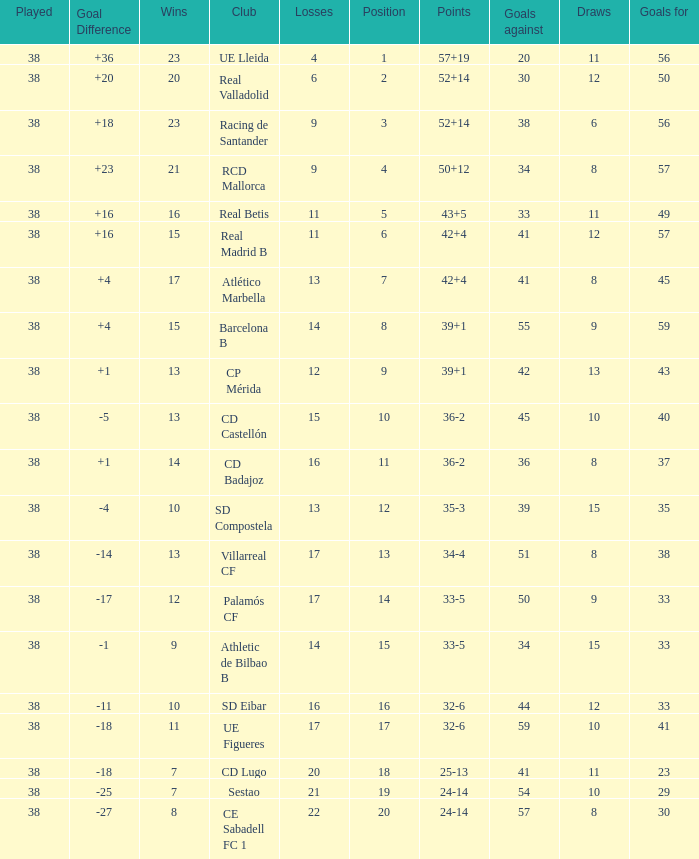What is the highest number played with a goal difference less than -27? None. 